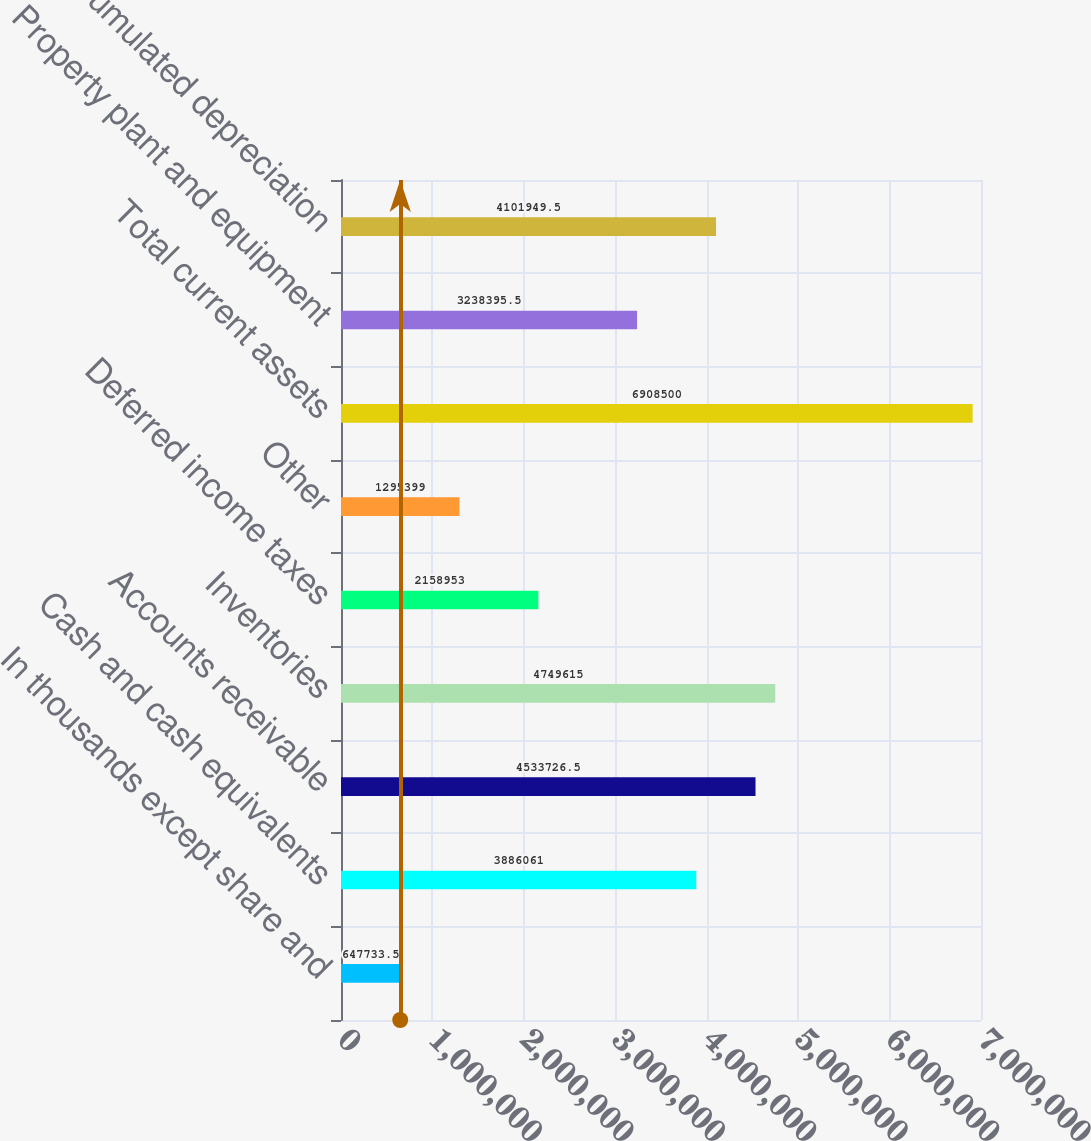Convert chart. <chart><loc_0><loc_0><loc_500><loc_500><bar_chart><fcel>In thousands except share and<fcel>Cash and cash equivalents<fcel>Accounts receivable<fcel>Inventories<fcel>Deferred income taxes<fcel>Other<fcel>Total current assets<fcel>Property plant and equipment<fcel>Accumulated depreciation<nl><fcel>647734<fcel>3.88606e+06<fcel>4.53373e+06<fcel>4.74962e+06<fcel>2.15895e+06<fcel>1.2954e+06<fcel>6.9085e+06<fcel>3.2384e+06<fcel>4.10195e+06<nl></chart> 